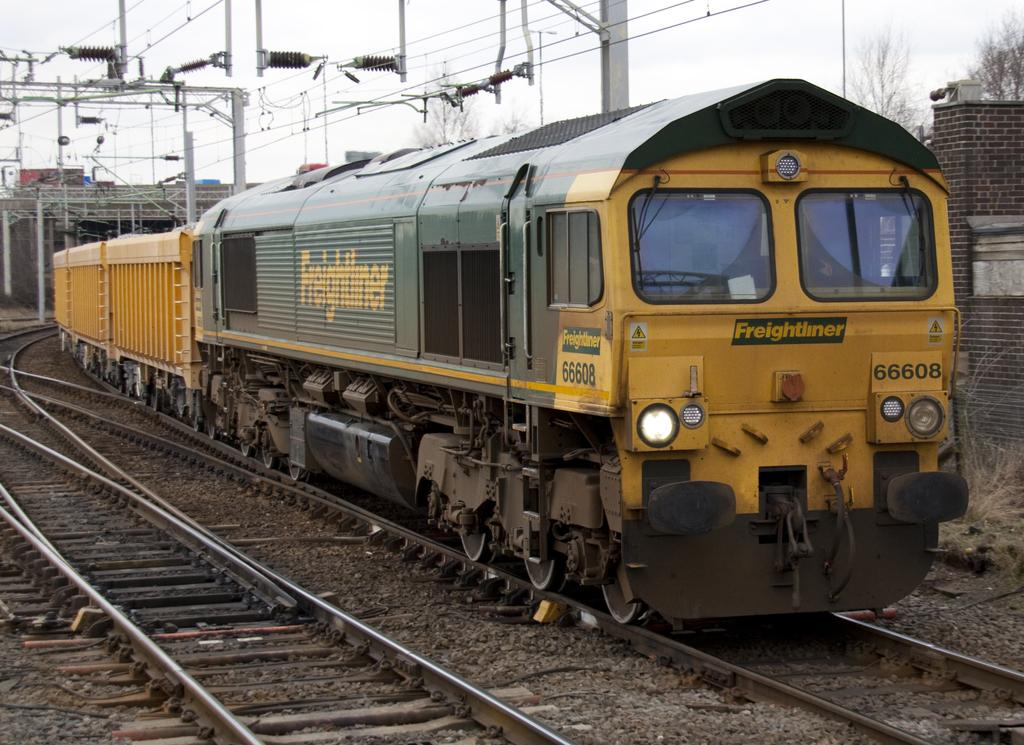What is the main subject of the image? The main subject of the image is a train. What is the train doing in the image? The train is moving on a railway track. What can be seen in the background of the image? In the background of the image, there is a brick wall, poles, wires, trees, and the sky. How does the train maintain its quiet operation in the image? The train's operation is not described as quiet in the image, and there is no indication of its noise level. --- Facts: 1. There is a person holding a camera in the image. 2. The person is standing on a bridge. 3. There is a river below the bridge. 4. The sky is visible in the background of the image. 5. There are clouds in the sky. Absurd Topics: dance, piano, ocean Conversation: What is the person in the image doing? The person in the image is holding a camera. Where is the person standing in the image? The person is standing on a bridge. What can be seen below the bridge in the image? There is a river below the bridge. What is visible in the background of the image? The sky is visible in the background of the image, with clouds present. Reasoning: Let's think step by step in order to produce the conversation. We start by identifying the main subject of the image, which is the person holding a camera. Then, we describe the location of the person, which is standing on a bridge. Next, we mention the river visible below the bridge. Finally, we describe the sky and clouds visible in the background of the image. Absurd Question/Answer: Can you tell me how the person is playing the piano in the image? There is no piano present in the image, so it cannot be determined if the person is playing one. --- Facts: 1. There is a car in the image. 2. The car is parked on the street. 3. There is a fire hydrant near the car. 4. There are trees in the background of the image. 5. The sky is visible in the background of the image. Absurd Topics: dance, piano, ocean Conversation: What is the main subject of the image? The main subject of the image is a car. Where is the car located in the image? The car is parked on the street. What can be seen near the car in the image? There is a fire hydrant near the car. What is visible in the background of the image? The sky and trees are visible in the background of the image. Reasoning: Let's think step by step in order to produce the conversation. We start by identifying the main subject of the image, which is the car. Then, we describe the location of the car, 